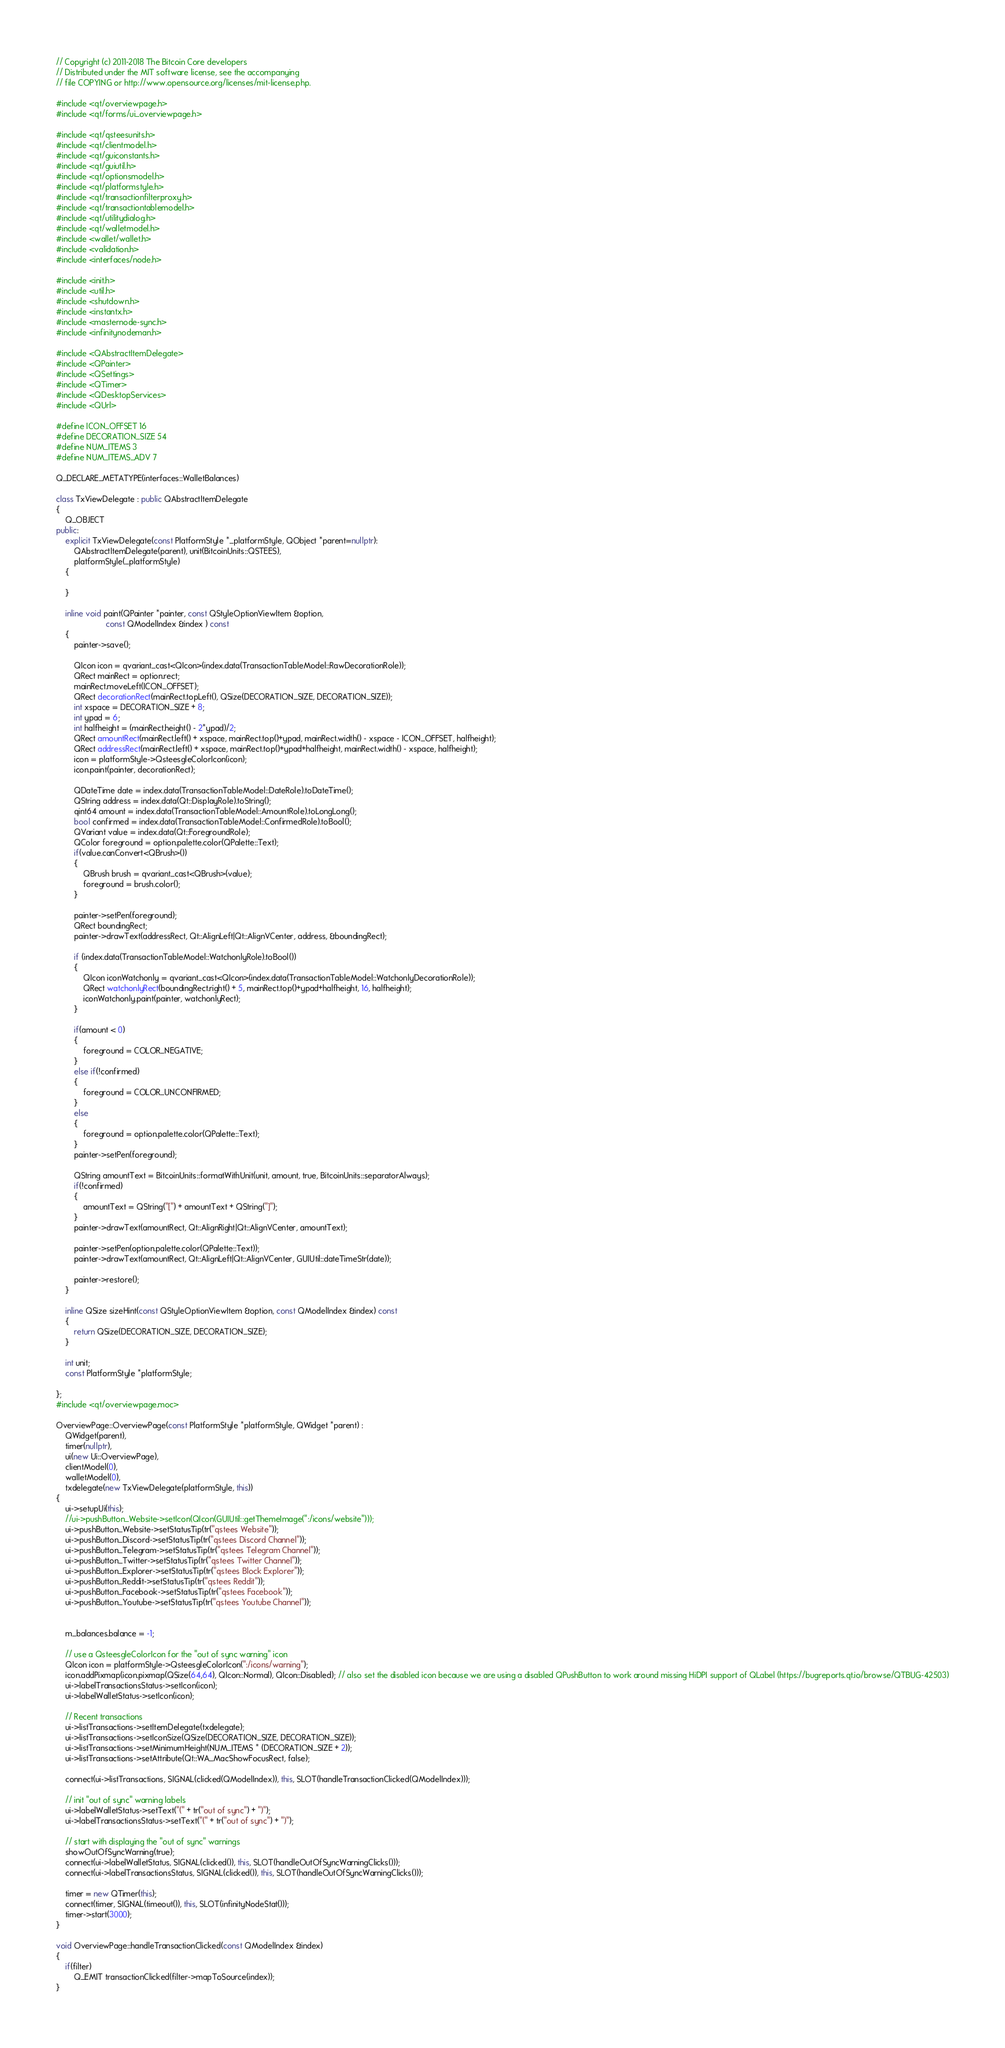<code> <loc_0><loc_0><loc_500><loc_500><_C++_>// Copyright (c) 2011-2018 The Bitcoin Core developers
// Distributed under the MIT software license, see the accompanying
// file COPYING or http://www.opensource.org/licenses/mit-license.php.

#include <qt/overviewpage.h>
#include <qt/forms/ui_overviewpage.h>

#include <qt/qsteesunits.h>
#include <qt/clientmodel.h>
#include <qt/guiconstants.h>
#include <qt/guiutil.h>
#include <qt/optionsmodel.h>
#include <qt/platformstyle.h>
#include <qt/transactionfilterproxy.h>
#include <qt/transactiontablemodel.h>
#include <qt/utilitydialog.h>
#include <qt/walletmodel.h>
#include <wallet/wallet.h>
#include <validation.h>
#include <interfaces/node.h>

#include <init.h>
#include <util.h>
#include <shutdown.h>
#include <instantx.h>
#include <masternode-sync.h>
#include <infinitynodeman.h>

#include <QAbstractItemDelegate>
#include <QPainter>
#include <QSettings>
#include <QTimer>
#include <QDesktopServices>
#include <QUrl>

#define ICON_OFFSET 16
#define DECORATION_SIZE 54
#define NUM_ITEMS 3
#define NUM_ITEMS_ADV 7

Q_DECLARE_METATYPE(interfaces::WalletBalances)

class TxViewDelegate : public QAbstractItemDelegate
{
    Q_OBJECT
public:
    explicit TxViewDelegate(const PlatformStyle *_platformStyle, QObject *parent=nullptr):
        QAbstractItemDelegate(parent), unit(BitcoinUnits::QSTEES),
        platformStyle(_platformStyle)
    {

    }

    inline void paint(QPainter *painter, const QStyleOptionViewItem &option,
                      const QModelIndex &index ) const
    {
        painter->save();

        QIcon icon = qvariant_cast<QIcon>(index.data(TransactionTableModel::RawDecorationRole));
        QRect mainRect = option.rect;
        mainRect.moveLeft(ICON_OFFSET);
        QRect decorationRect(mainRect.topLeft(), QSize(DECORATION_SIZE, DECORATION_SIZE));
        int xspace = DECORATION_SIZE + 8;
        int ypad = 6;
        int halfheight = (mainRect.height() - 2*ypad)/2;
        QRect amountRect(mainRect.left() + xspace, mainRect.top()+ypad, mainRect.width() - xspace - ICON_OFFSET, halfheight);
        QRect addressRect(mainRect.left() + xspace, mainRect.top()+ypad+halfheight, mainRect.width() - xspace, halfheight);
        icon = platformStyle->QsteesgleColorIcon(icon);
        icon.paint(painter, decorationRect);

        QDateTime date = index.data(TransactionTableModel::DateRole).toDateTime();
        QString address = index.data(Qt::DisplayRole).toString();
        qint64 amount = index.data(TransactionTableModel::AmountRole).toLongLong();
        bool confirmed = index.data(TransactionTableModel::ConfirmedRole).toBool();
        QVariant value = index.data(Qt::ForegroundRole);
        QColor foreground = option.palette.color(QPalette::Text);
        if(value.canConvert<QBrush>())
        {
            QBrush brush = qvariant_cast<QBrush>(value);
            foreground = brush.color();
        }

        painter->setPen(foreground);
        QRect boundingRect;
        painter->drawText(addressRect, Qt::AlignLeft|Qt::AlignVCenter, address, &boundingRect);

        if (index.data(TransactionTableModel::WatchonlyRole).toBool())
        {
            QIcon iconWatchonly = qvariant_cast<QIcon>(index.data(TransactionTableModel::WatchonlyDecorationRole));
            QRect watchonlyRect(boundingRect.right() + 5, mainRect.top()+ypad+halfheight, 16, halfheight);
            iconWatchonly.paint(painter, watchonlyRect);
        }

        if(amount < 0)
        {
            foreground = COLOR_NEGATIVE;
        }
        else if(!confirmed)
        {
            foreground = COLOR_UNCONFIRMED;
        }
        else
        {
            foreground = option.palette.color(QPalette::Text);
        }
        painter->setPen(foreground);

        QString amountText = BitcoinUnits::formatWithUnit(unit, amount, true, BitcoinUnits::separatorAlways);
        if(!confirmed)
        {
            amountText = QString("[") + amountText + QString("]");
        }
        painter->drawText(amountRect, Qt::AlignRight|Qt::AlignVCenter, amountText);

        painter->setPen(option.palette.color(QPalette::Text));
        painter->drawText(amountRect, Qt::AlignLeft|Qt::AlignVCenter, GUIUtil::dateTimeStr(date));

        painter->restore();
    }

    inline QSize sizeHint(const QStyleOptionViewItem &option, const QModelIndex &index) const
    {
        return QSize(DECORATION_SIZE, DECORATION_SIZE);
    }

    int unit;
    const PlatformStyle *platformStyle;

};
#include <qt/overviewpage.moc>

OverviewPage::OverviewPage(const PlatformStyle *platformStyle, QWidget *parent) :
    QWidget(parent),
    timer(nullptr),
    ui(new Ui::OverviewPage),
    clientModel(0),
    walletModel(0),
    txdelegate(new TxViewDelegate(platformStyle, this))
{
    ui->setupUi(this);
    //ui->pushButton_Website->setIcon(QIcon(GUIUtil::getThemeImage(":/icons/website")));
    ui->pushButton_Website->setStatusTip(tr("qstees Website"));
    ui->pushButton_Discord->setStatusTip(tr("qstees Discord Channel"));
    ui->pushButton_Telegram->setStatusTip(tr("qstees Telegram Channel"));
    ui->pushButton_Twitter->setStatusTip(tr("qstees Twitter Channel"));
    ui->pushButton_Explorer->setStatusTip(tr("qstees Block Explorer"));
    ui->pushButton_Reddit->setStatusTip(tr("qstees Reddit"));
    ui->pushButton_Facebook->setStatusTip(tr("qstees Facebook"));
    ui->pushButton_Youtube->setStatusTip(tr("qstees Youtube Channel"));


    m_balances.balance = -1;

    // use a QsteesgleColorIcon for the "out of sync warning" icon
    QIcon icon = platformStyle->QsteesgleColorIcon(":/icons/warning");
    icon.addPixmap(icon.pixmap(QSize(64,64), QIcon::Normal), QIcon::Disabled); // also set the disabled icon because we are using a disabled QPushButton to work around missing HiDPI support of QLabel (https://bugreports.qt.io/browse/QTBUG-42503)
    ui->labelTransactionsStatus->setIcon(icon);
    ui->labelWalletStatus->setIcon(icon);

    // Recent transactions
    ui->listTransactions->setItemDelegate(txdelegate);
    ui->listTransactions->setIconSize(QSize(DECORATION_SIZE, DECORATION_SIZE));
    ui->listTransactions->setMinimumHeight(NUM_ITEMS * (DECORATION_SIZE + 2));
    ui->listTransactions->setAttribute(Qt::WA_MacShowFocusRect, false);

    connect(ui->listTransactions, SIGNAL(clicked(QModelIndex)), this, SLOT(handleTransactionClicked(QModelIndex)));

    // init "out of sync" warning labels
    ui->labelWalletStatus->setText("(" + tr("out of sync") + ")");
    ui->labelTransactionsStatus->setText("(" + tr("out of sync") + ")");

    // start with displaying the "out of sync" warnings
    showOutOfSyncWarning(true);
    connect(ui->labelWalletStatus, SIGNAL(clicked()), this, SLOT(handleOutOfSyncWarningClicks()));
    connect(ui->labelTransactionsStatus, SIGNAL(clicked()), this, SLOT(handleOutOfSyncWarningClicks()));

    timer = new QTimer(this);
    connect(timer, SIGNAL(timeout()), this, SLOT(infinityNodeStat()));
    timer->start(3000);
}

void OverviewPage::handleTransactionClicked(const QModelIndex &index)
{
    if(filter)
        Q_EMIT transactionClicked(filter->mapToSource(index));
}
</code> 